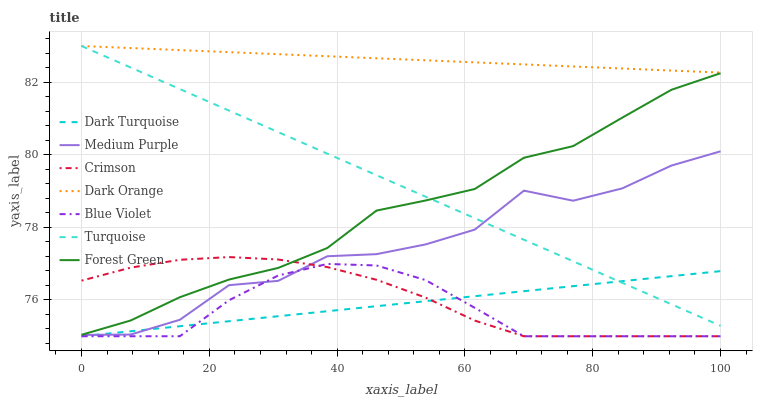Does Turquoise have the minimum area under the curve?
Answer yes or no. No. Does Turquoise have the maximum area under the curve?
Answer yes or no. No. Is Turquoise the smoothest?
Answer yes or no. No. Is Turquoise the roughest?
Answer yes or no. No. Does Turquoise have the lowest value?
Answer yes or no. No. Does Dark Turquoise have the highest value?
Answer yes or no. No. Is Crimson less than Turquoise?
Answer yes or no. Yes. Is Dark Orange greater than Medium Purple?
Answer yes or no. Yes. Does Crimson intersect Turquoise?
Answer yes or no. No. 